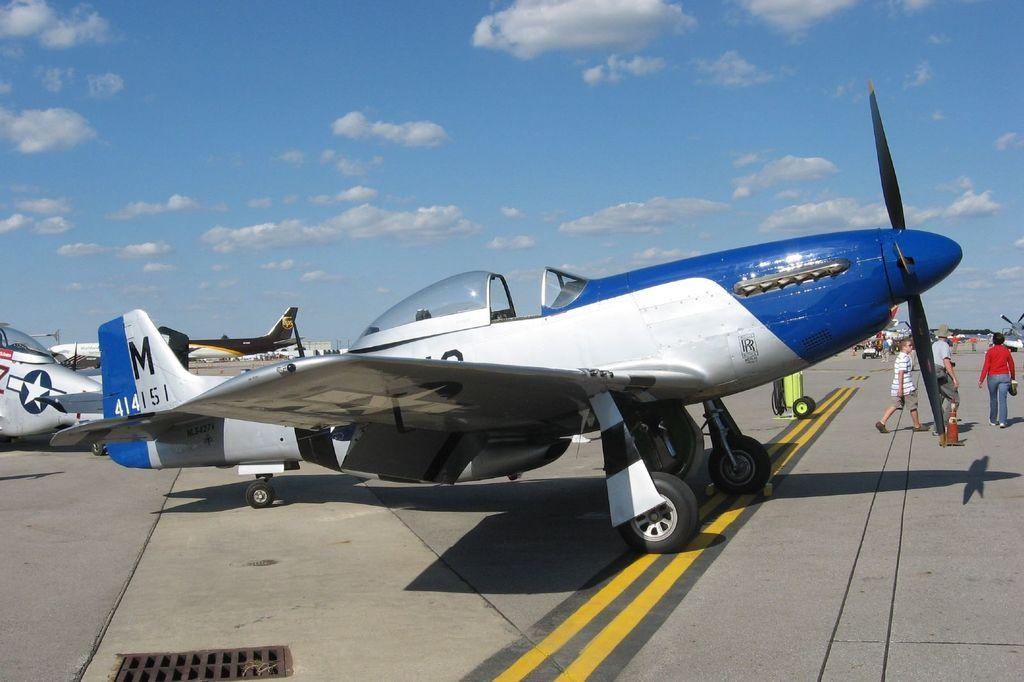<image>
Give a short and clear explanation of the subsequent image. A blue and white plane with M on the tail sits on the runway. 